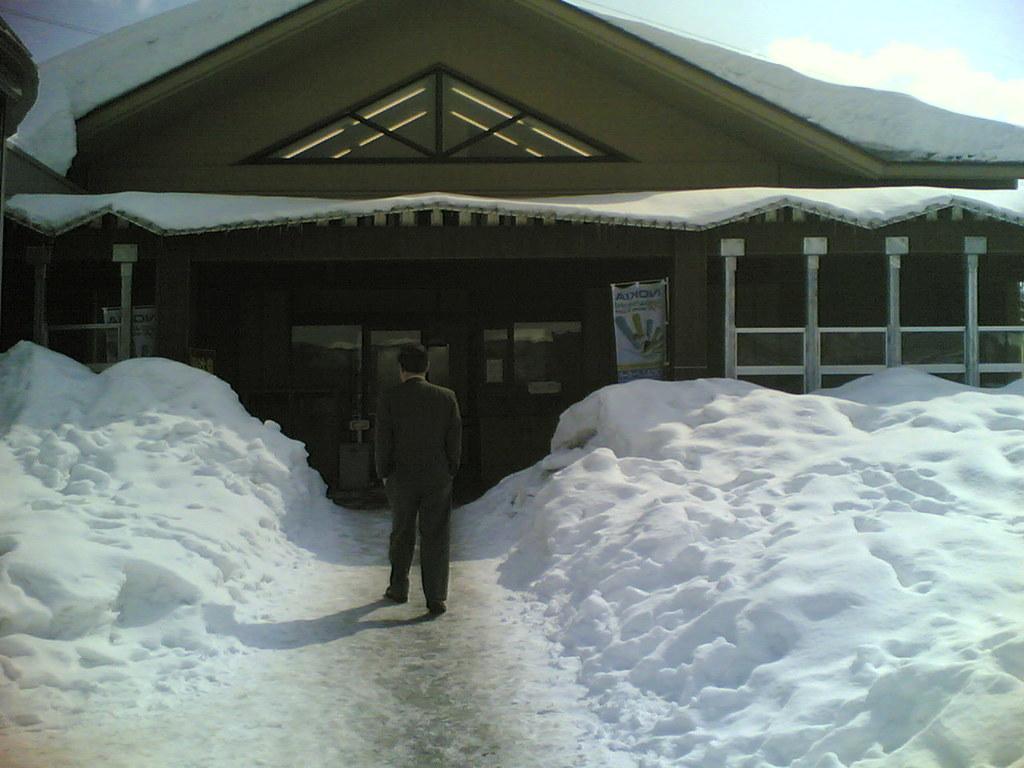Can you describe this image briefly? In this image we can see a person is standing, he is wearing coat. Behind his house is there. To the right and left side of the image snow is present. 